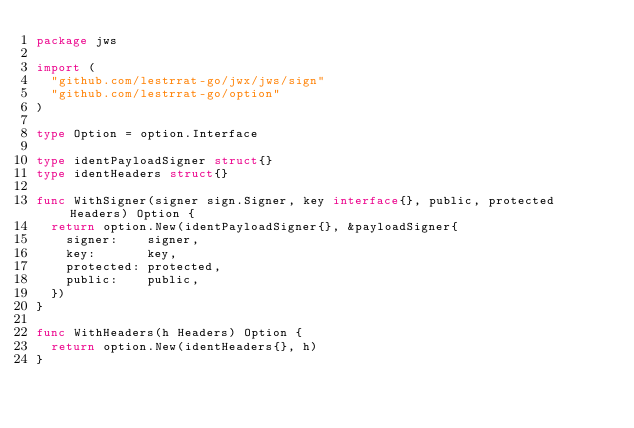<code> <loc_0><loc_0><loc_500><loc_500><_Go_>package jws

import (
	"github.com/lestrrat-go/jwx/jws/sign"
	"github.com/lestrrat-go/option"
)

type Option = option.Interface

type identPayloadSigner struct{}
type identHeaders struct{}

func WithSigner(signer sign.Signer, key interface{}, public, protected Headers) Option {
	return option.New(identPayloadSigner{}, &payloadSigner{
		signer:    signer,
		key:       key,
		protected: protected,
		public:    public,
	})
}

func WithHeaders(h Headers) Option {
	return option.New(identHeaders{}, h)
}
</code> 